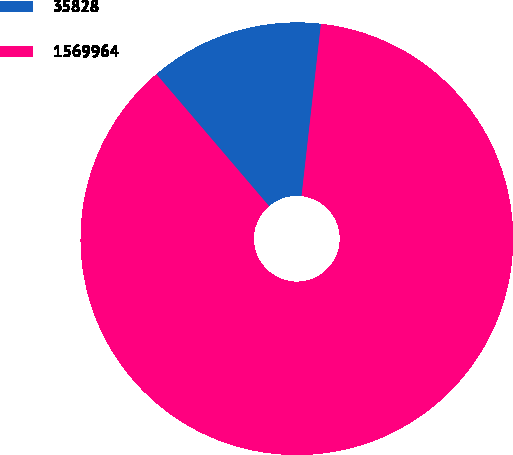<chart> <loc_0><loc_0><loc_500><loc_500><pie_chart><fcel>35828<fcel>1569964<nl><fcel>13.03%<fcel>86.97%<nl></chart> 